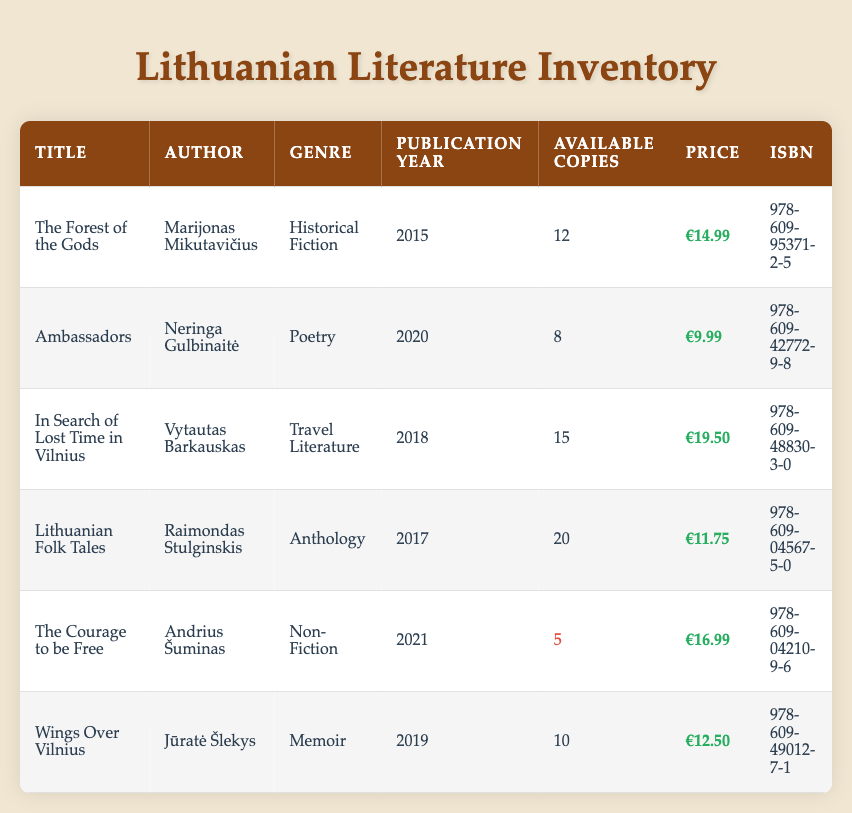What is the title of the book authored by Jūratė Šlekys? The table lists the authors along with their respective book titles. By locating Jūratė Šlekys in the Author column, we find that the corresponding title in the Title column is "Wings Over Vilnius."
Answer: Wings Over Vilnius How many available copies of "The Courage to be Free" are there? Looking at the table, we can find the book "The Courage to be Free" in the Title column. The number of available copies is listed next to it in the Available Copies column, which shows there are 5 copies.
Answer: 5 What genre does "In Search of Lost Time in Vilnius" belong to? By searching for "In Search of Lost Time in Vilnius" in the Title column, we can see the corresponding genre listed in the Genre column, which is "Travel Literature."
Answer: Travel Literature What is the total number of available copies for all the books published after 2017? We first identify the books published after 2017: "Ambassadors" (8), "In Search of Lost Time in Vilnius" (15), "The Courage to be Free" (5), and "Wings Over Vilnius" (10). Adding these together: 8 + 15 + 5 + 10 = 38.
Answer: 38 Is there a book with more than 15 available copies? By examining the Available Copies column, we see that the books "Lithuanian Folk Tales" (20) and "In Search of Lost Time in Vilnius" (15) have 15 or more copies, which confirms there is at least one book with more than 15 available copies.
Answer: Yes What is the difference in price between the most expensive and the cheapest book in the inventory? To find the highest and lowest prices, we look at the Price column. The most expensive book is "In Search of Lost Time in Vilnius" at €19.50, and the cheapest is "Ambassadors" at €9.99. The difference is calculated as €19.50 - €9.99 = €9.51.
Answer: €9.51 What is the average price of the books available in the inventory? To calculate the average, we first sum the prices: €14.99 + €9.99 + €19.50 + €11.75 + €16.99 + €12.50 = €85.72. Then, divide this total by the number of books, which is 6. So, €85.72 / 6 ≈ €14.29.
Answer: €14.29 Are there any poetry books in the inventory? By checking the Genre column, we identify "Ambassadors" under the Poetry category, confirming that there is a poetry book in the inventory.
Answer: Yes 